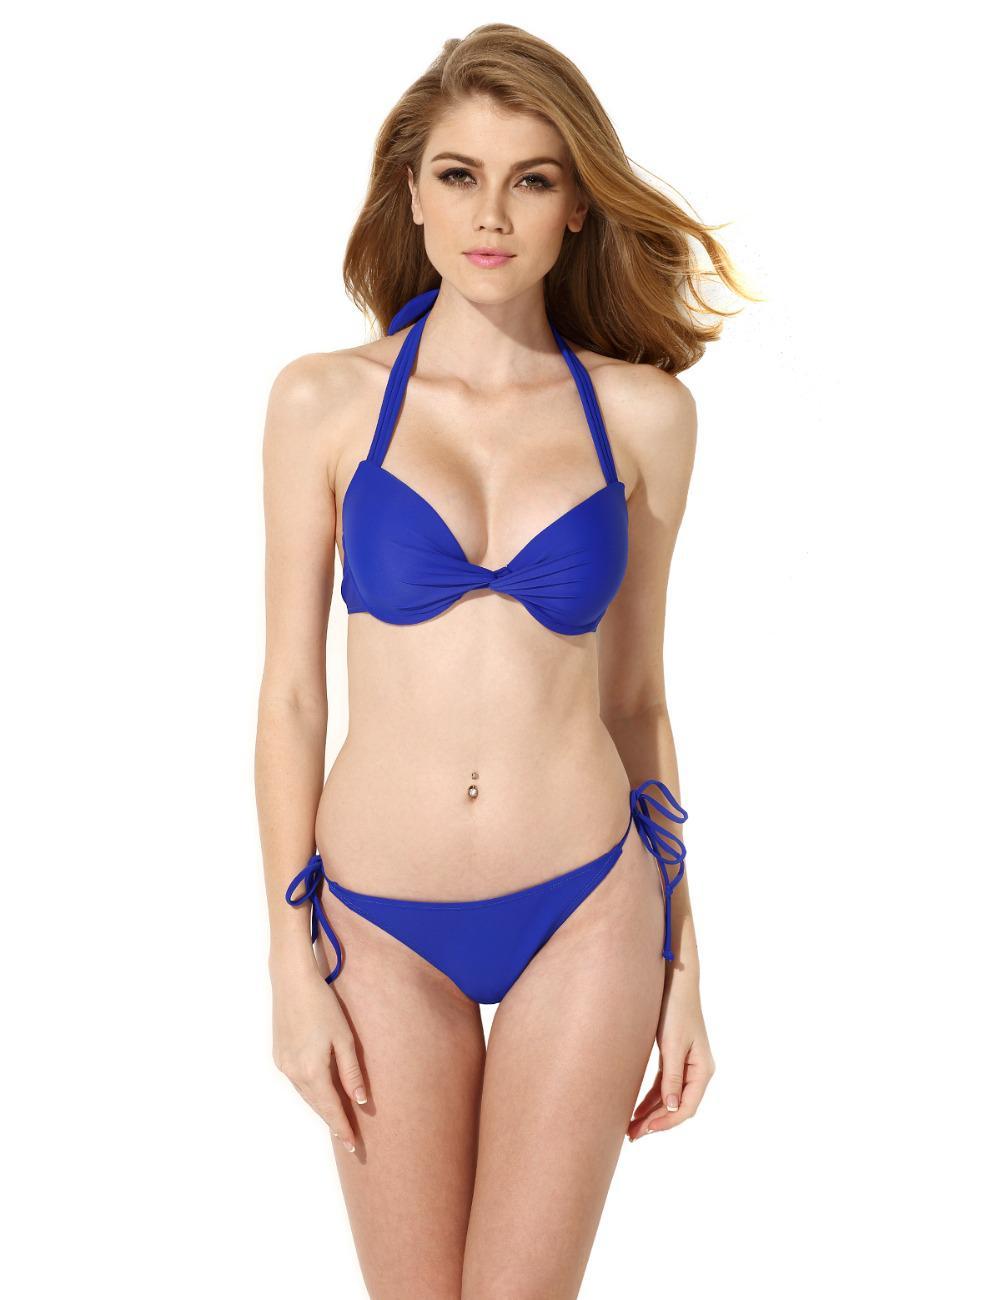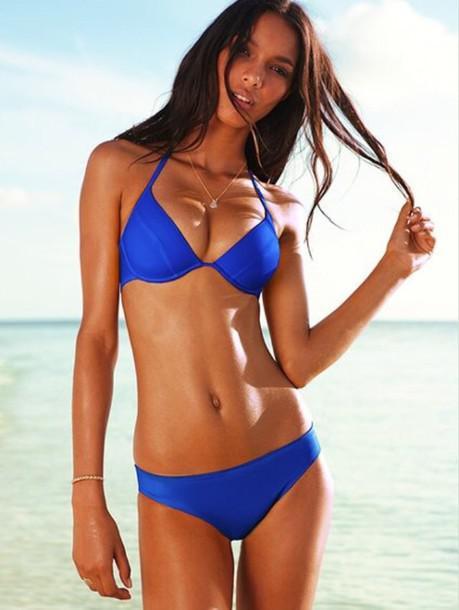The first image is the image on the left, the second image is the image on the right. Considering the images on both sides, is "models are wearing high wasted bikini bottoms" valid? Answer yes or no. No. 